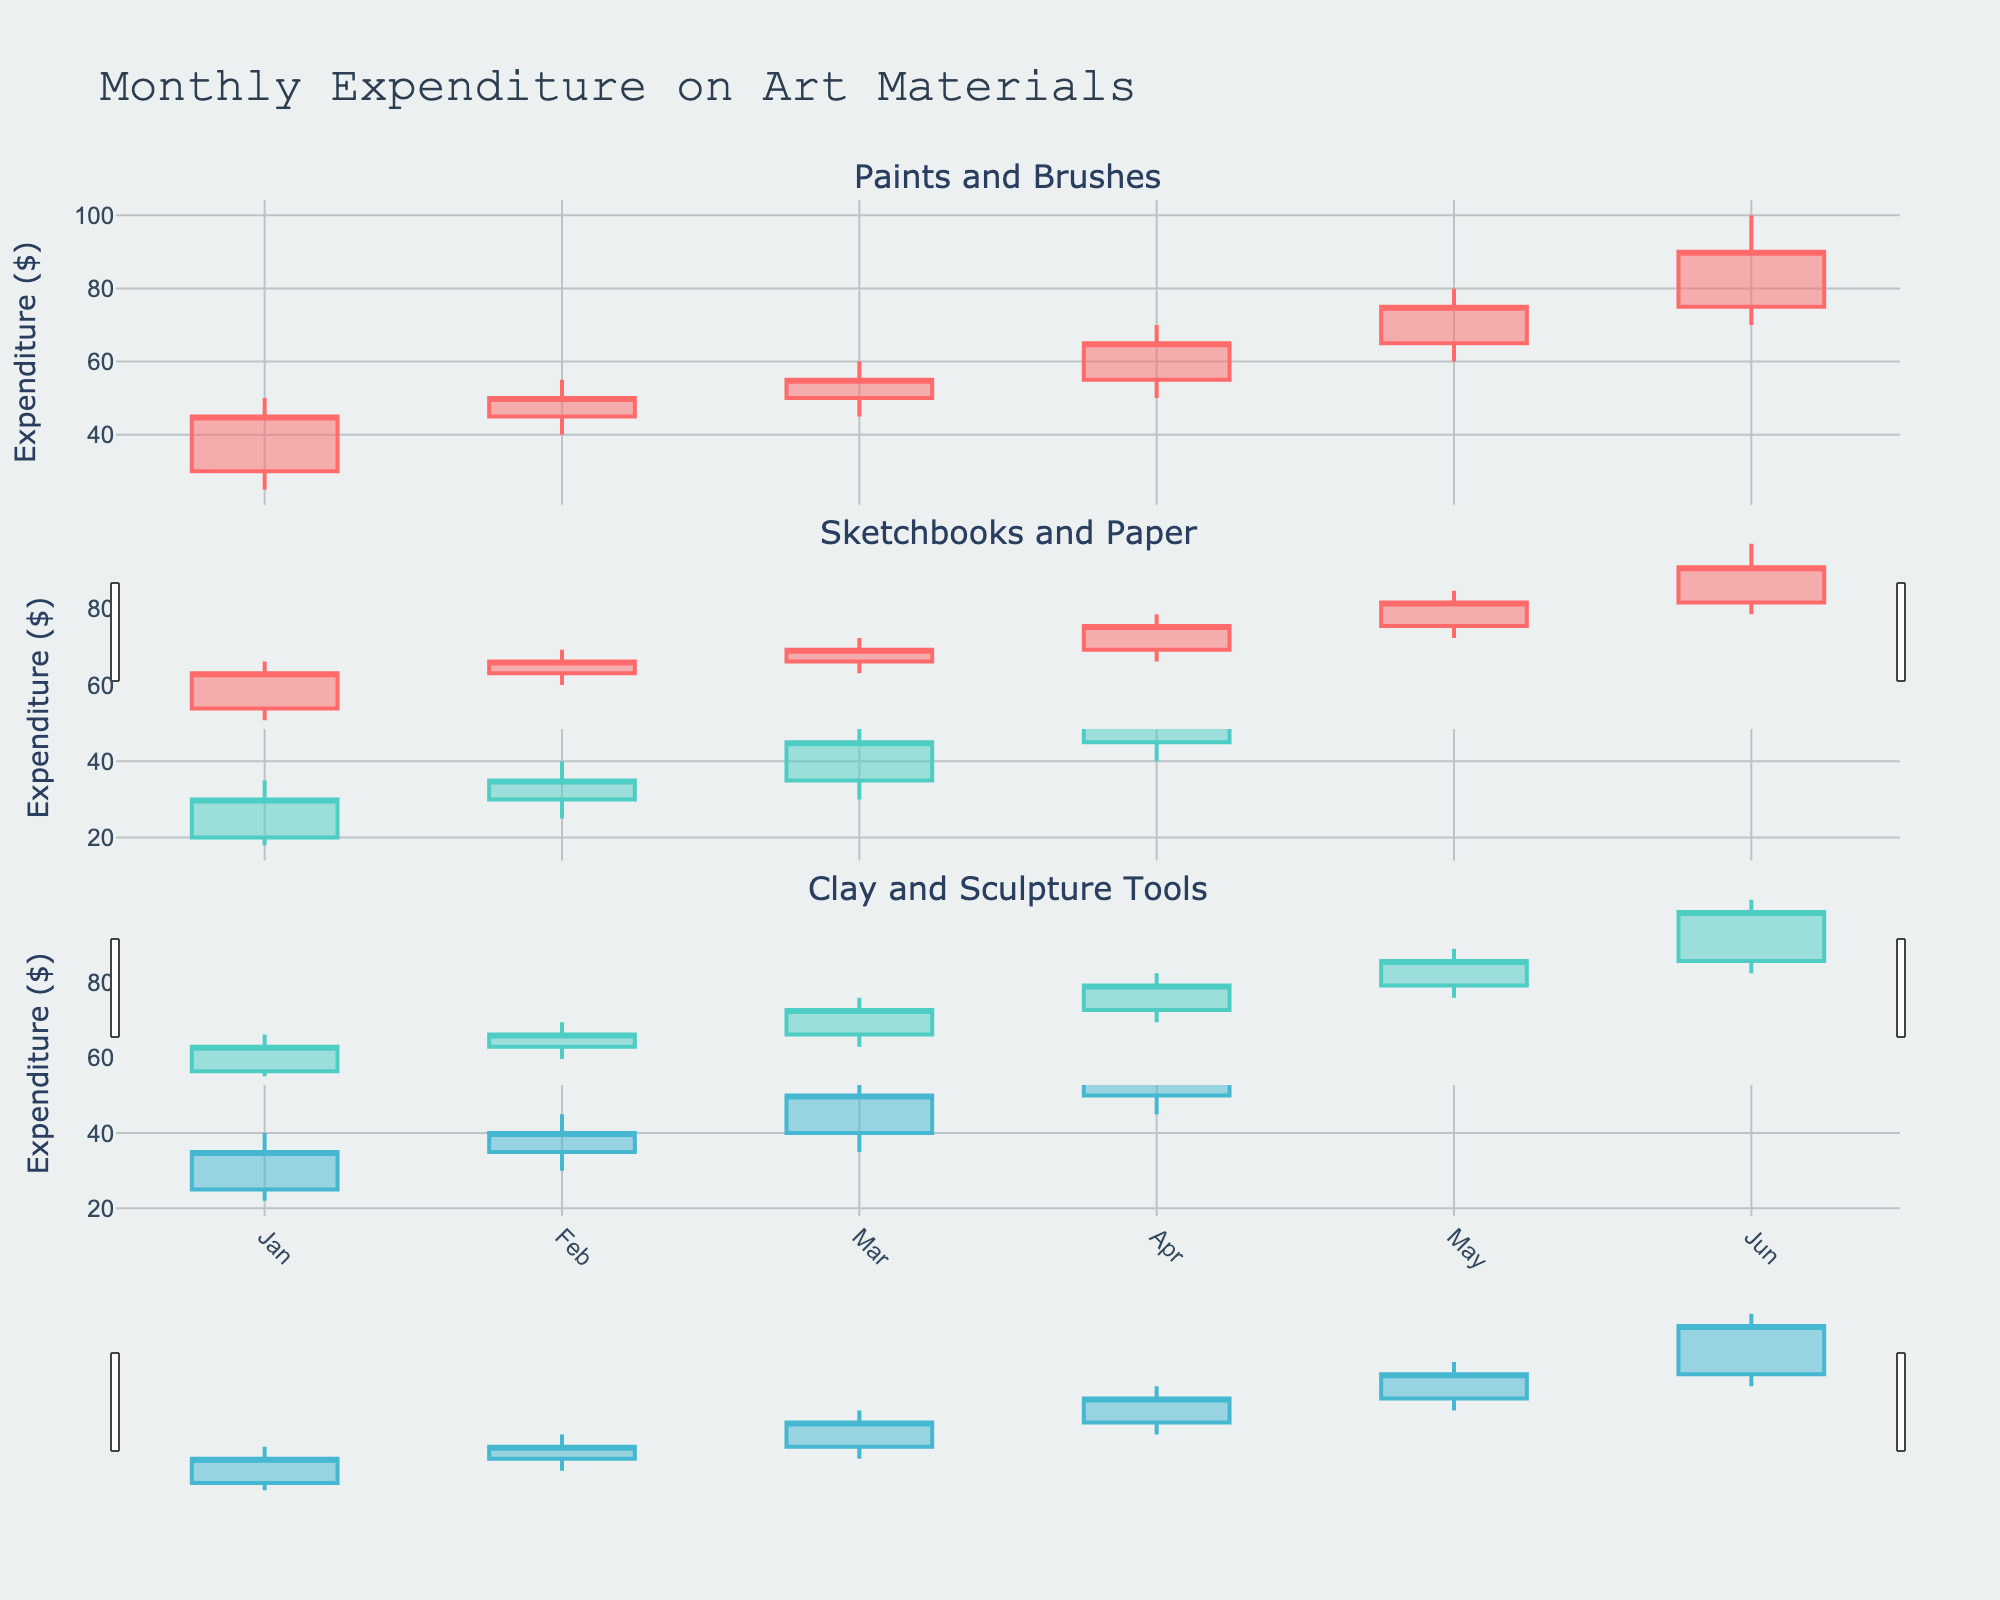What is the title of the plot? The title can be found at the top of the plot. It reads "Monthly Expenditure on Art Materials".
Answer: Monthly Expenditure on Art Materials Which art material had the highest closing expenditure in May? Look at May for each art material (Paints and Brushes, Sketchbooks and Paper, Clay and Sculpture Tools) and check the closing values. The closing values are highest in May for "Paints and Brushes" at $75.
Answer: Paints and Brushes During which month did "Sketchbooks and Paper" have the lowest expenditure, and what was the value? For "Sketchbooks and Paper", check the low values for each month. It was lowest in January with a value of $18.
Answer: January, $18 How much did the expenditure on "Clay and Sculpture Tools" increase from February to March? Check the closing value in February for "Clay and Sculpture Tools" ($40) and in March ($50). The difference is $50 - $40 = $10.
Answer: $10 Which art material shows the highest volatility in April, and how can you tell? Volatility can be assessed by the range (difference between high and low values). In April, "Paints and Brushes" has a high of $70 and a low of $50, giving a range of $20. This is higher compared to the other materials.
Answer: Paints and Brushes What was the highest expenditure (high) recorded for "Sketchbooks and Paper", and in which month did it occur? Check the high values for "Sketchbooks and Paper" across the months. The highest expenditure was $90 in June.
Answer: $90, June Compare the closing expenditure in January and June for "Paints and Brushes". By how much did it increase? The closing expenditure for "Paints and Brushes" in January was $45 and in June it was $90. The increase is $90 - $45 = $45.
Answer: $45 Which entity had the smallest range in May, and what was the range value? Calculate the range by subtracting the low from the high value for each entity in May: "Paints and Brushes" (80-60=20), "Sketchbooks and Paper" (70-50=20), "Clay and Sculpture Tools" (75-55=20). All have the smallest range of $20.
Answer: All entities, $20 What was the closing expenditure for "Clay and Sculpture Tools" in the last month depicted in the plot? The last month in the data is June. The closing expenditure for "Clay and Sculpture Tools" in June is $90.
Answer: $90 